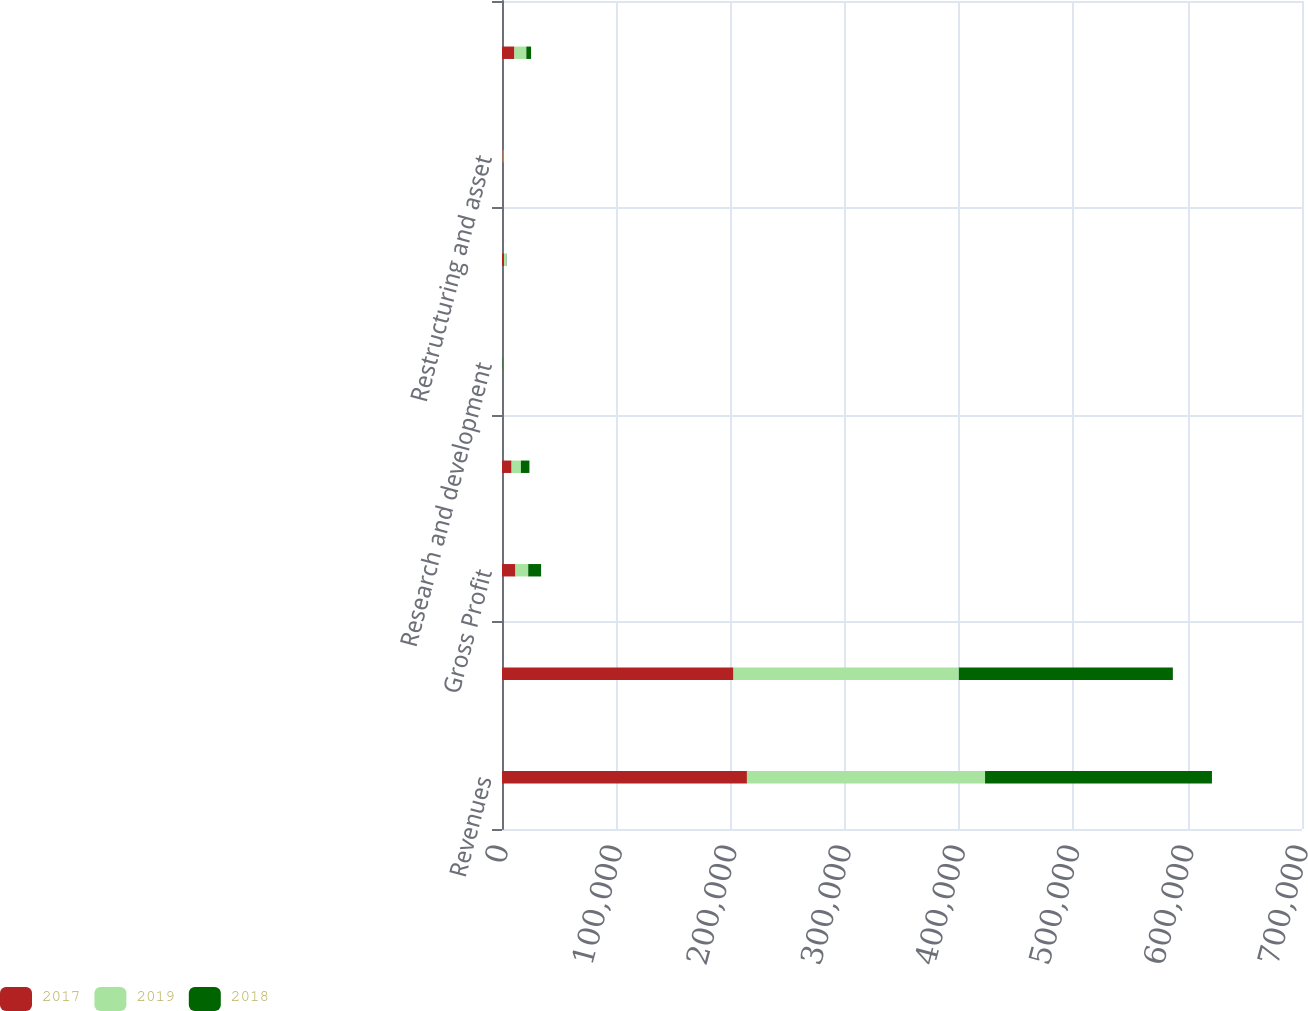<chart> <loc_0><loc_0><loc_500><loc_500><stacked_bar_chart><ecel><fcel>Revenues<fcel>Cost of Sales<fcel>Gross Profit<fcel>Selling distribution and<fcel>Research and development<fcel>Goodwill impairment charges<fcel>Restructuring and asset<fcel>Total Operating Expenses<nl><fcel>2017<fcel>214319<fcel>202565<fcel>11754<fcel>8403<fcel>71<fcel>1797<fcel>597<fcel>10868<nl><fcel>2019<fcel>208357<fcel>197173<fcel>11184<fcel>8138<fcel>125<fcel>1738<fcel>567<fcel>10422<nl><fcel>2018<fcel>198533<fcel>187262<fcel>11271<fcel>7447<fcel>341<fcel>290<fcel>18<fcel>4149<nl></chart> 